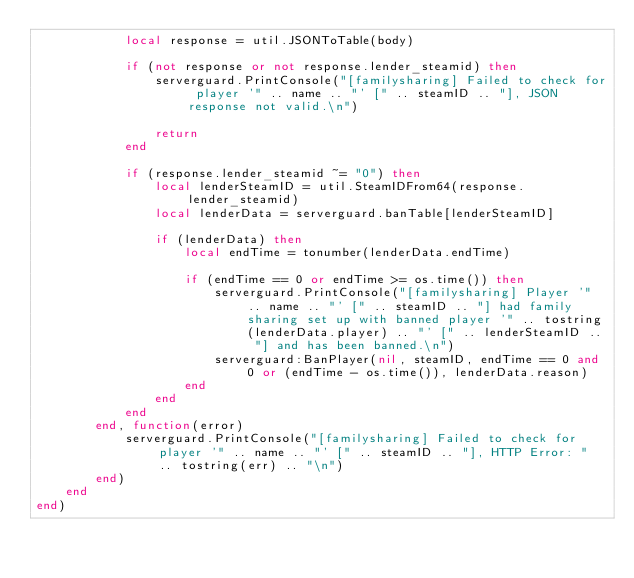Convert code to text. <code><loc_0><loc_0><loc_500><loc_500><_Lua_>            local response = util.JSONToTable(body)

            if (not response or not response.lender_steamid) then
                serverguard.PrintConsole("[familysharing] Failed to check for player '" .. name .. "' [" .. steamID .. "], JSON response not valid.\n")

                return
            end

            if (response.lender_steamid ~= "0") then
                local lenderSteamID = util.SteamIDFrom64(response.lender_steamid)
                local lenderData = serverguard.banTable[lenderSteamID]

                if (lenderData) then
                    local endTime = tonumber(lenderData.endTime)

                    if (endTime == 0 or endTime >= os.time()) then
                        serverguard.PrintConsole("[familysharing] Player '" .. name .. "' [" .. steamID .. "] had family sharing set up with banned player '" .. tostring(lenderData.player) .. "' [" .. lenderSteamID .. "] and has been banned.\n")
                        serverguard:BanPlayer(nil, steamID, endTime == 0 and 0 or (endTime - os.time()), lenderData.reason)
                    end
                end
            end
        end, function(error)
            serverguard.PrintConsole("[familysharing] Failed to check for player '" .. name .. "' [" .. steamID .. "], HTTP Error: " .. tostring(err) .. "\n")
        end)
    end
end)</code> 